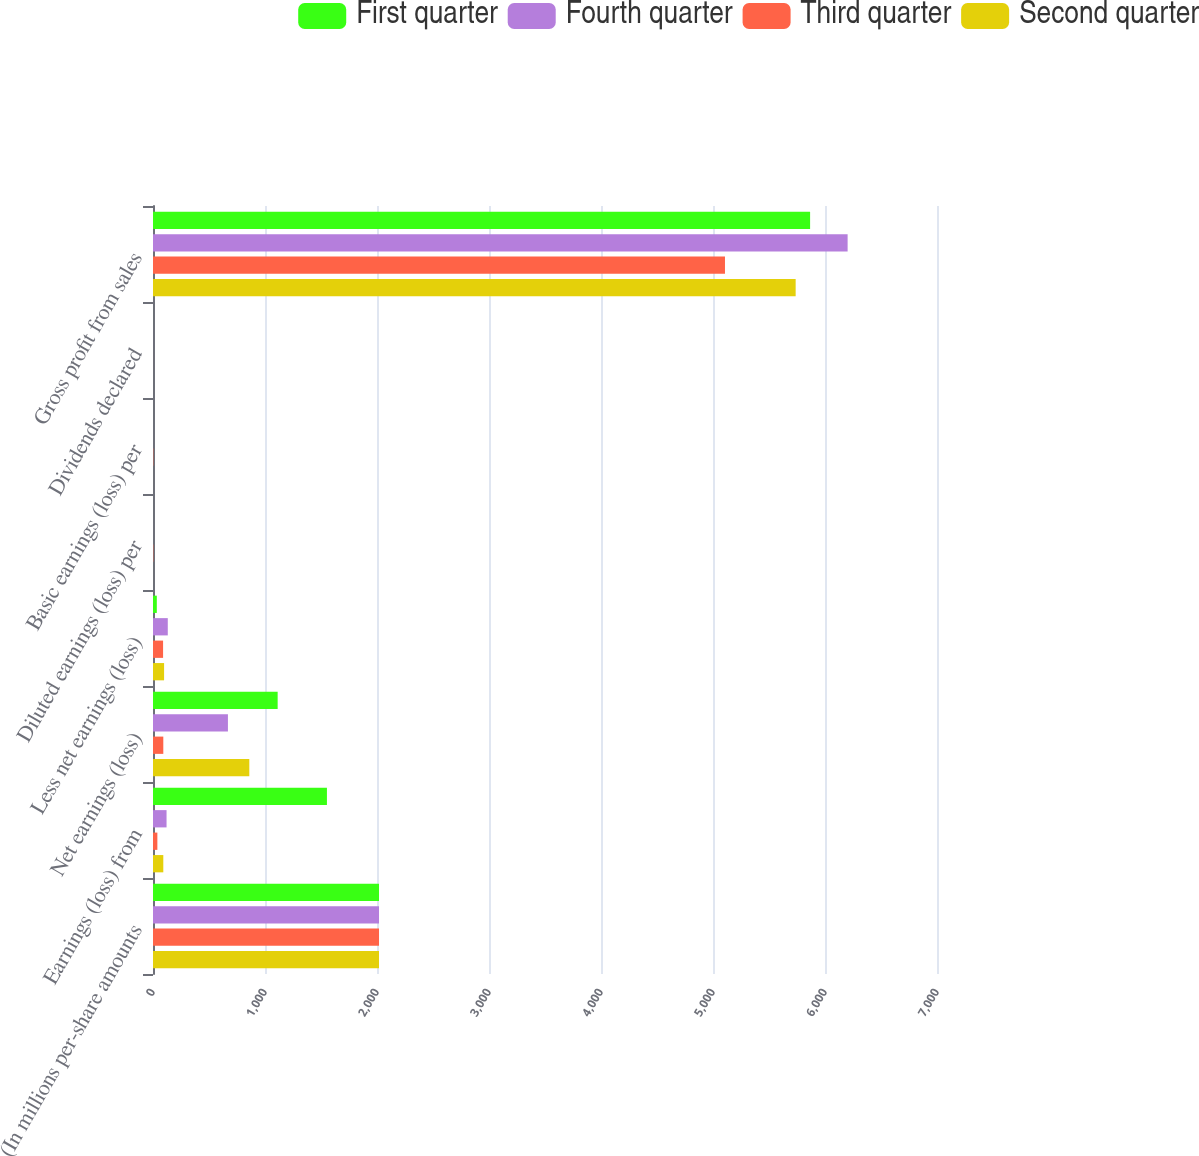Convert chart. <chart><loc_0><loc_0><loc_500><loc_500><stacked_bar_chart><ecel><fcel>(In millions per-share amounts<fcel>Earnings (loss) from<fcel>Net earnings (loss)<fcel>Less net earnings (loss)<fcel>Diluted earnings (loss) per<fcel>Basic earnings (loss) per<fcel>Dividends declared<fcel>Gross profit from sales<nl><fcel>First quarter<fcel>2018<fcel>1553<fcel>1113<fcel>34<fcel>0.04<fcel>0.04<fcel>0.12<fcel>5867<nl><fcel>Fourth quarter<fcel>2018<fcel>121<fcel>669<fcel>132<fcel>0.08<fcel>0.08<fcel>0.12<fcel>6202<nl><fcel>Third quarter<fcel>2018<fcel>39<fcel>92<fcel>90<fcel>2.63<fcel>2.63<fcel>0.12<fcel>5107<nl><fcel>Second quarter<fcel>2018<fcel>92<fcel>860<fcel>99<fcel>0.08<fcel>0.08<fcel>0.01<fcel>5738<nl></chart> 